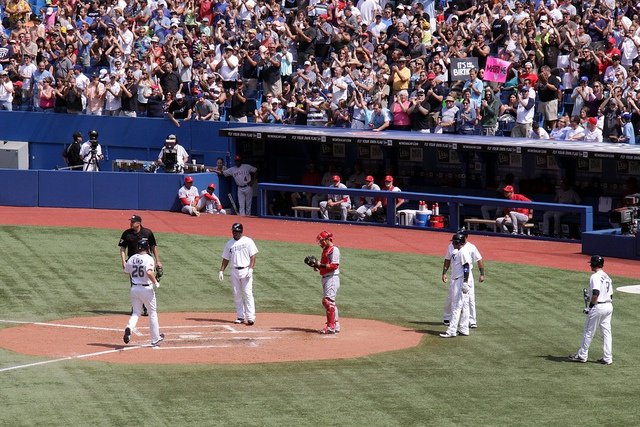Describe the objects in this image and their specific colors. I can see people in black, gray, lavender, and maroon tones, people in black, lavender, darkgray, and gray tones, people in black, lavender, and darkgray tones, people in black, darkgray, and lavender tones, and people in black, maroon, lavender, gray, and brown tones in this image. 